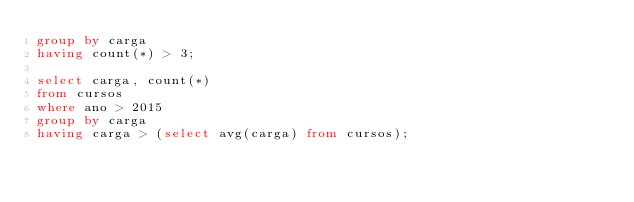<code> <loc_0><loc_0><loc_500><loc_500><_SQL_>group by carga
having count(*) > 3;

select carga, count(*) 
from cursos
where ano > 2015
group by carga
having carga > (select avg(carga) from cursos);</code> 